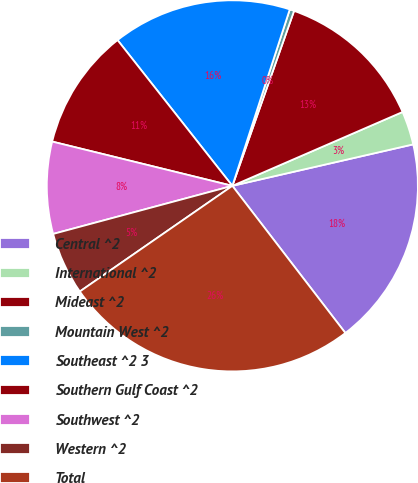Convert chart to OTSL. <chart><loc_0><loc_0><loc_500><loc_500><pie_chart><fcel>Central ^2<fcel>International ^2<fcel>Mideast ^2<fcel>Mountain West ^2<fcel>Southeast ^2 3<fcel>Southern Gulf Coast ^2<fcel>Southwest ^2<fcel>Western ^2<fcel>Total<nl><fcel>18.17%<fcel>2.93%<fcel>13.09%<fcel>0.39%<fcel>15.63%<fcel>10.55%<fcel>8.01%<fcel>5.47%<fcel>25.79%<nl></chart> 